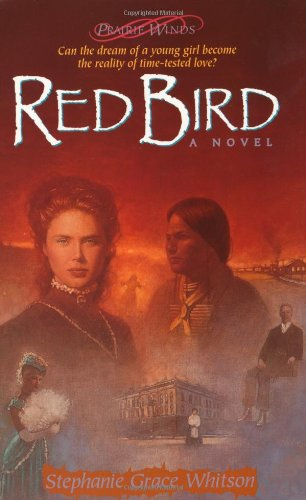Who wrote this book?
Answer the question using a single word or phrase. Stephanie Grace Whitson What is the title of this book? Red Bird (Prairie Winds Series #3) What type of book is this? Religion & Spirituality Is this a religious book? Yes Is this a recipe book? No 